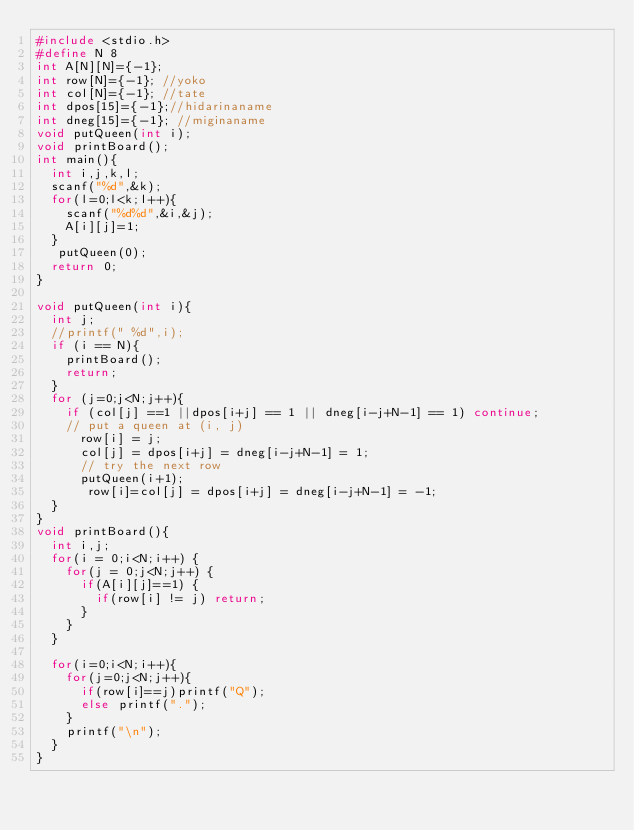Convert code to text. <code><loc_0><loc_0><loc_500><loc_500><_C_>#include <stdio.h>
#define N 8
int A[N][N]={-1};
int row[N]={-1}; //yoko
int col[N]={-1}; //tate
int dpos[15]={-1};//hidarinaname
int dneg[15]={-1}; //miginaname
void putQueen(int i);
void printBoard();     
int main(){
  int i,j,k,l;
  scanf("%d",&k);
  for(l=0;l<k;l++){
    scanf("%d%d",&i,&j);
    A[i][j]=1;
  }
   putQueen(0);
  return 0;
}

void putQueen(int i){
  int j;
  //printf(" %d",i);
  if (i == N){
    printBoard();
    return;
  }
  for (j=0;j<N;j++){
    if (col[j] ==1 ||dpos[i+j] == 1 || dneg[i-j+N-1] == 1) continue;
    // put a queen at (i, j)
      row[i] = j;
      col[j] = dpos[i+j] = dneg[i-j+N-1] = 1;
      // try the next row
      putQueen(i+1);
       row[i]=col[j] = dpos[i+j] = dneg[i-j+N-1] = -1;
  }
}
void printBoard(){
  int i,j;
  for(i = 0;i<N;i++) {
    for(j = 0;j<N;j++) {
      if(A[i][j]==1) {
        if(row[i] != j) return;
      }
    }
  }
  
  for(i=0;i<N;i++){
    for(j=0;j<N;j++){
      if(row[i]==j)printf("Q");
      else printf(".");
    }
    printf("\n");
  }
}</code> 